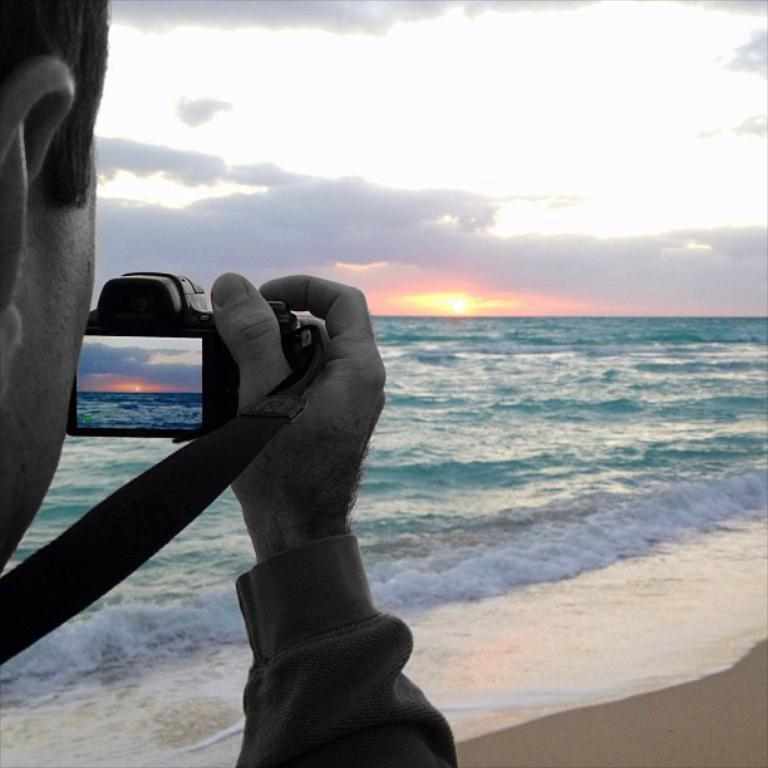Who is taking the picture in the image? There is a person holding the camera in the image. What can be seen in the background of the image? Water, the sun, clouds, and the sky are visible in the image. What is the color of the water in the image? The water has a green color. Can you describe the weather conditions in the image? The presence of clouds and the visible sun suggest it is partly cloudy. What type of low-fat food can be seen on the seashore in the image? There is no food or seashore present in the image; it features a person holding a camera and a green-colored body of water in the background. 